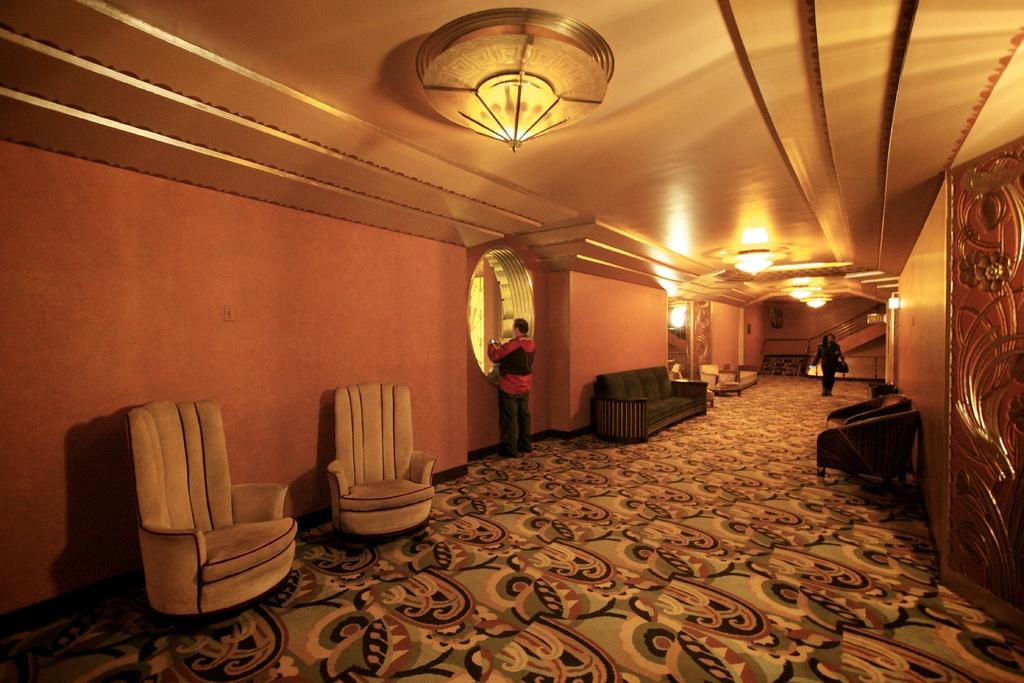Where was the image taken? The image was taken indoors. What type of furniture is present in the image? There is a sofa and chairs in the image. Are there any architectural features visible in the image? Yes, there are stairs in the image. What can be seen at the top of the image? There are lights visible at the top of the image. How many people are in the image? There are two people standing in the image. What type of butter is being used by the people in the image? There is no butter present in the image, and the people are not engaged in any activity that would involve using butter. 